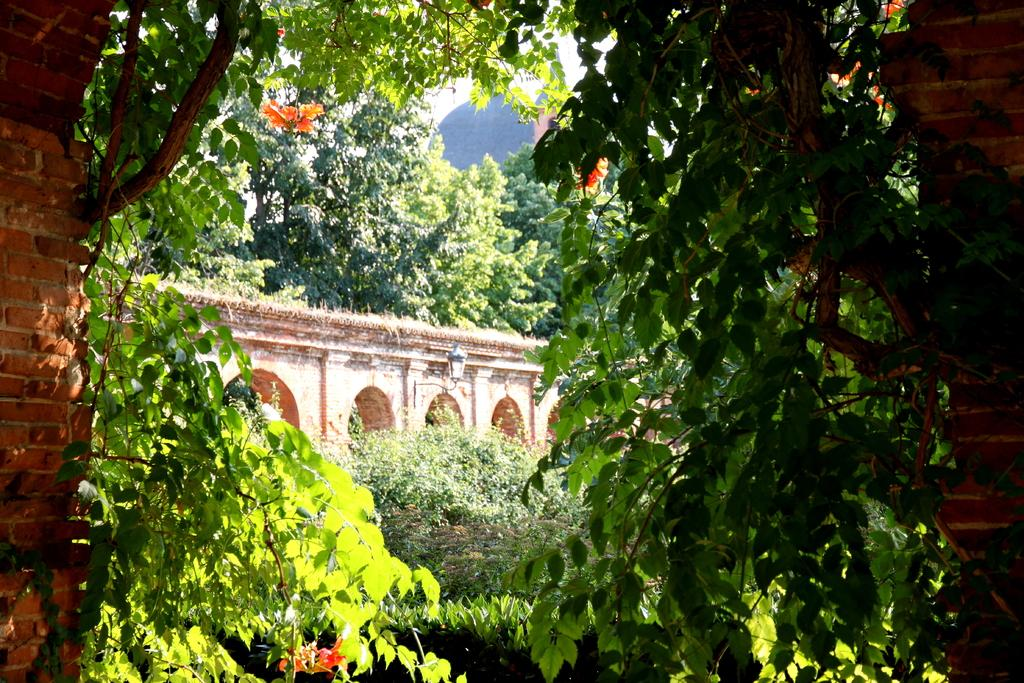What type of vegetation can be seen in the image? There are trees in the image. What structure can be seen in the background of the image? There appears to be a bridge in the background of the image. What type of wall is present on both sides of the image? There is a brick wall on the left side and the right side of the image. What can be used for illumination in the image? A light is visible in the image. What type of reward can be seen hanging from the trees in the image? There is no reward hanging from the trees in the image; only trees are present. What type of toys can be seen scattered around the brick walls in the image? There are no toys present in the image; only brick walls and trees are visible. 